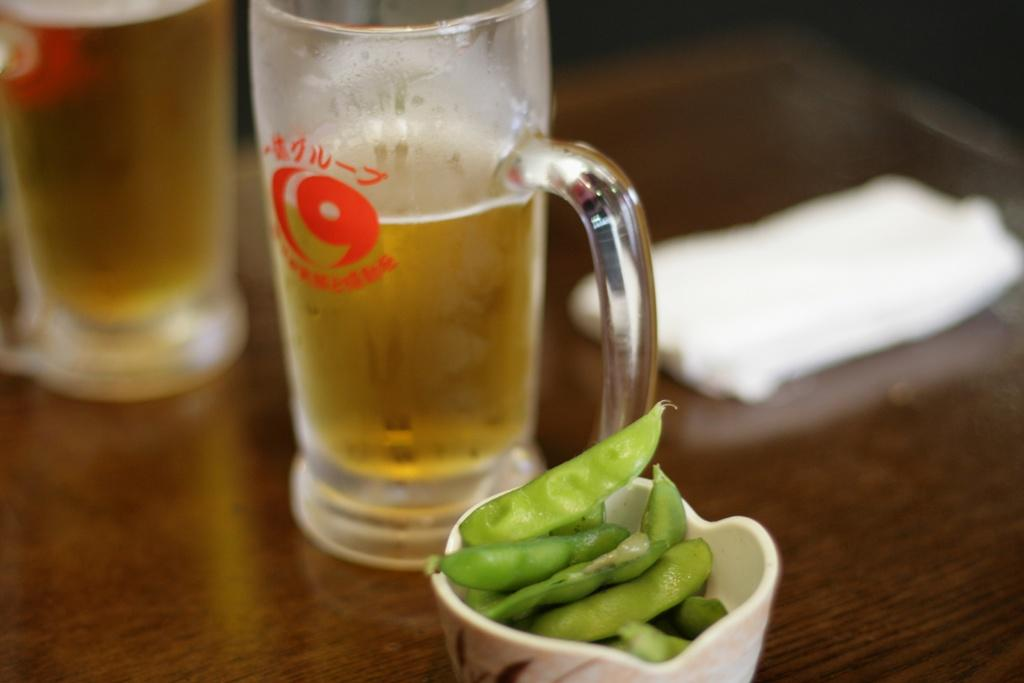What type of beverage is in the glasses in the image? There are two glasses of beer in the image. What other type of container is visible in the image? There is a cup in the image. What material is the cloth made of in the image? The cloth in the image is made of an unspecified material. What type of food is present in the image? There are beans in the image. Where are the objects placed in the image? The objects are placed on a table. Can you see any snails crawling on the table in the image? There are no snails present in the image. Is there any indication that someone is about to smash the cup in the image? There is no indication of any destructive action in the image; the objects are simply placed on the table. 